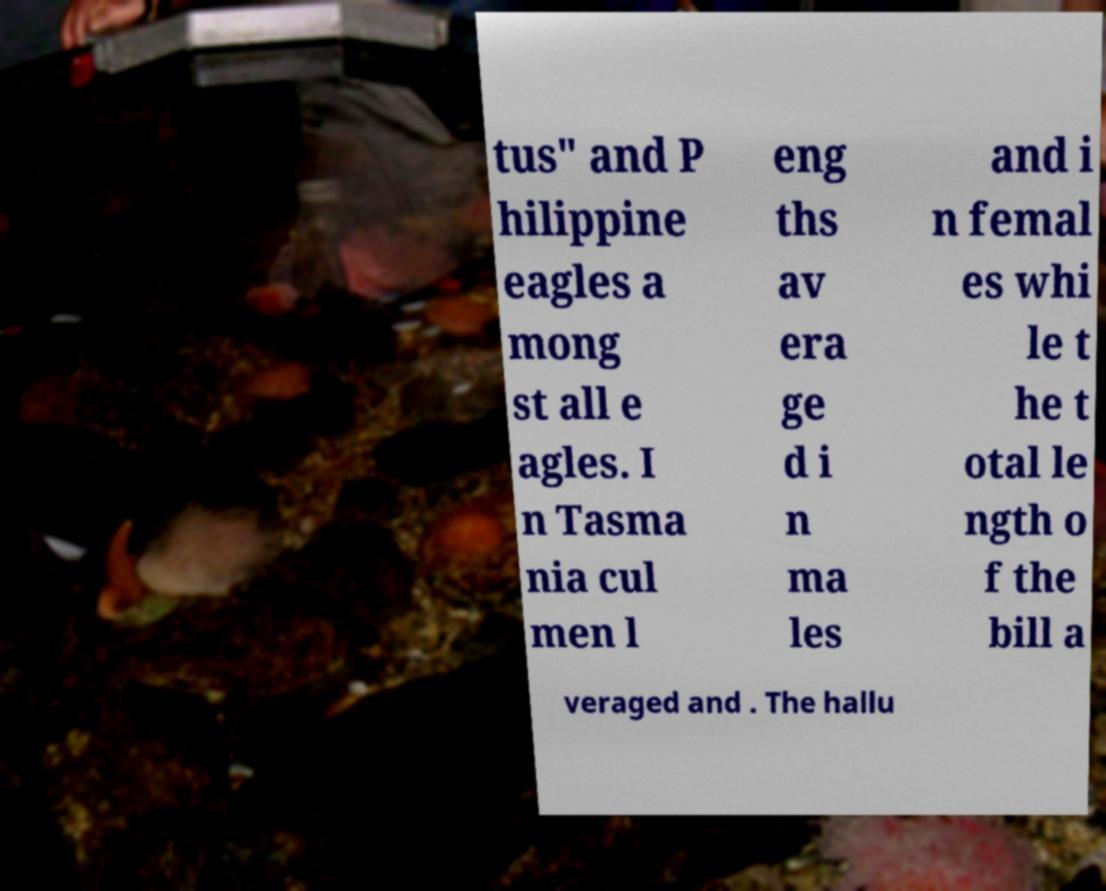What messages or text are displayed in this image? I need them in a readable, typed format. tus" and P hilippine eagles a mong st all e agles. I n Tasma nia cul men l eng ths av era ge d i n ma les and i n femal es whi le t he t otal le ngth o f the bill a veraged and . The hallu 